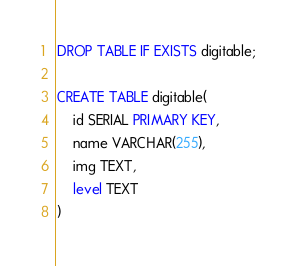<code> <loc_0><loc_0><loc_500><loc_500><_SQL_>DROP TABLE IF EXISTS digitable;

CREATE TABLE digitable(
    id SERIAL PRIMARY KEY,
    name VARCHAR(255),
    img TEXT,
    level TEXT
)</code> 